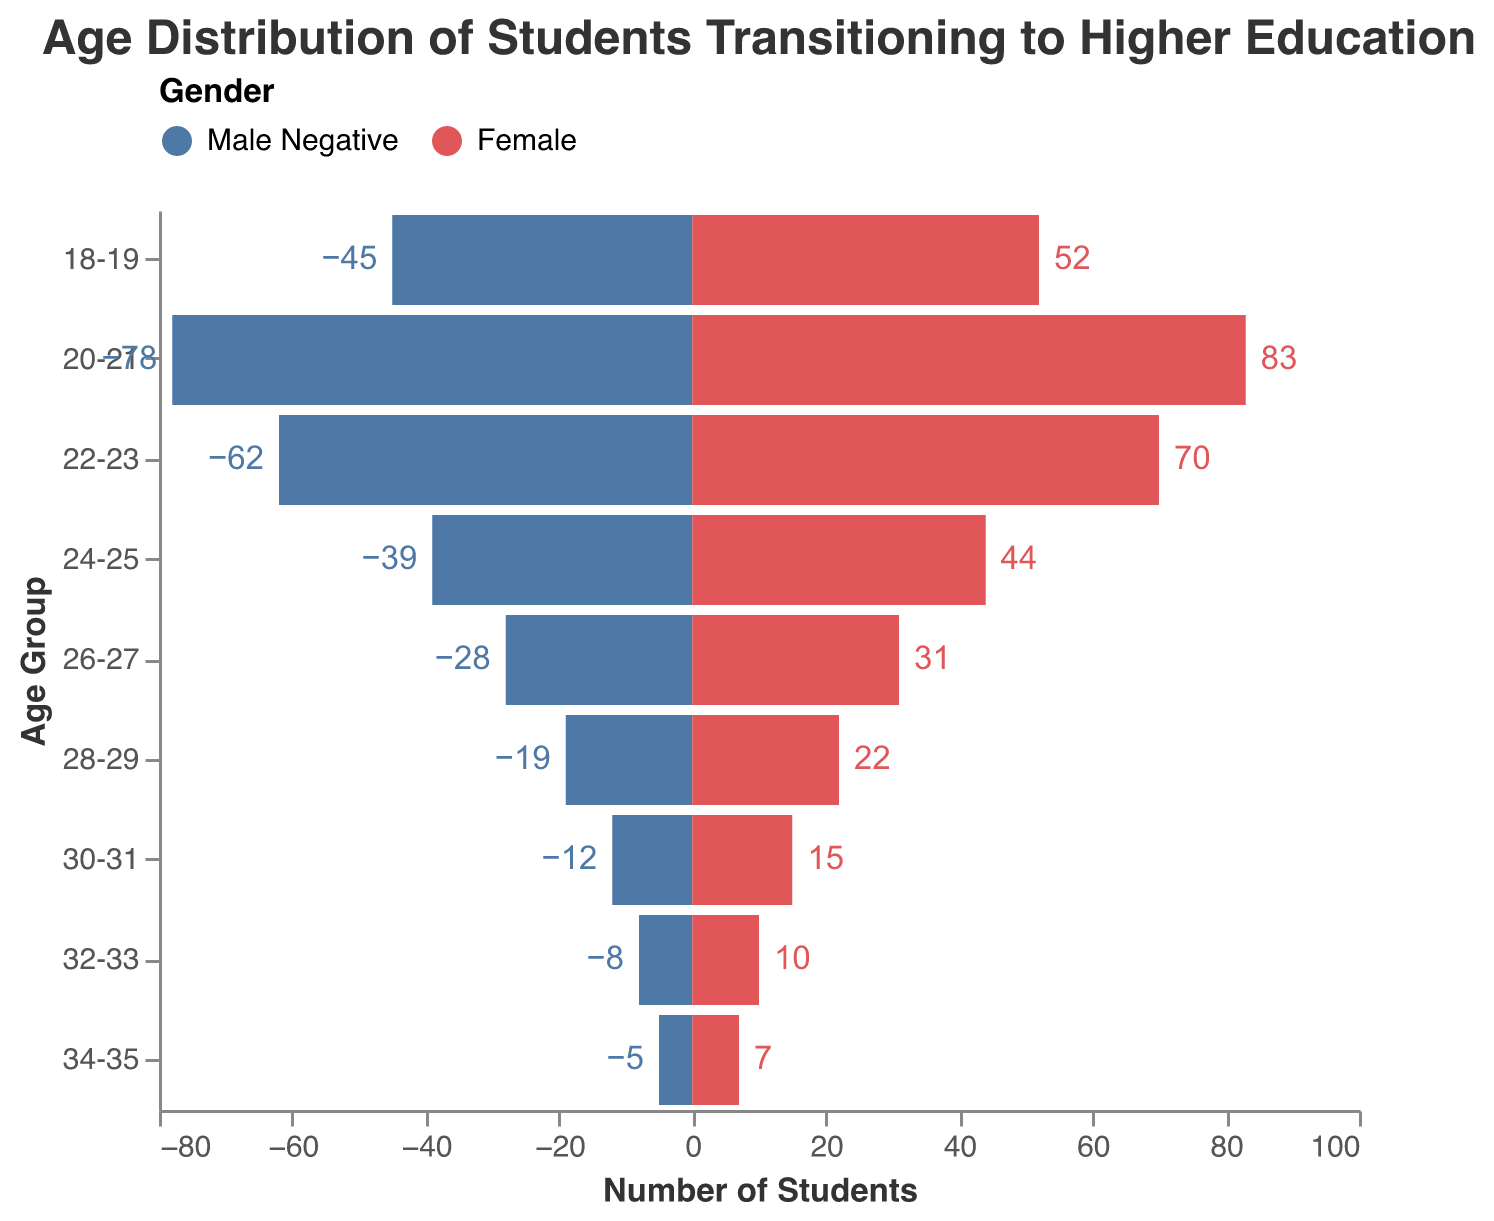What is the age group with the highest number of female students? The age group with the highest number of female students corresponds to the largest bar on the female side. From the figure, it is the 20-21 age group.
Answer: 20-21 How many age groups are represented in the chart? Count the distinct age groups shown along the y-axis. From the figure, these are "18-19", "20-21", "22-23", "24-25", "26-27", "28-29", "30-31", "32-33", and "34-35".
Answer: 9 Which gender has more students in the 22-23 age group, and by how many? Compare the heights of the bars for males and females in the 22-23 age group. Males have 62 students, while females have 70. The difference is 70 - 62.
Answer: Female, by 8 What is the total number of students aged 26-27? Add the number of male students to the number of female students in the 26-27 age group. That is 28 males + 31 females.
Answer: 59 What is the average number of male students across all age groups? Sum the number of male students for all age groups and divide by the total number of age groups: (45 + 78 + 62 + 39 + 28 + 19 + 12 + 8 + 5) / 9.
Answer: 33 In which age groups are there more male students than female students? Compare the number of male and female students in each age group. The age groups where males outnumber females are "26-27", "28-29", "30-31", "32-33", and "34-35".
Answer: 26-27, 28-29, 30-31, 32-33, 34-35 What is the total number of students in the 18-19 and 24-25 age groups combined? Add the number of male and female students for these age groups: (45 + 52) for 18-19 and (39 + 44) for 24-25. Sum them together: (45 + 52) + (39 + 44).
Answer: 180 Are there any age groups where the numbers of male and female students are equal? Check if there is any age group where the number of male students equals the number of female students. From the figure, there is no such age group.
Answer: No Which age group has the lowest number of students overall, and how many students are there in total in that age group? Identify the age group with the smallest bars combined on both gender sides. This is the "34-35" age group with 5 male students and 7 female students. Add them together: 5 + 7.
Answer: 34-35, with 12 students 